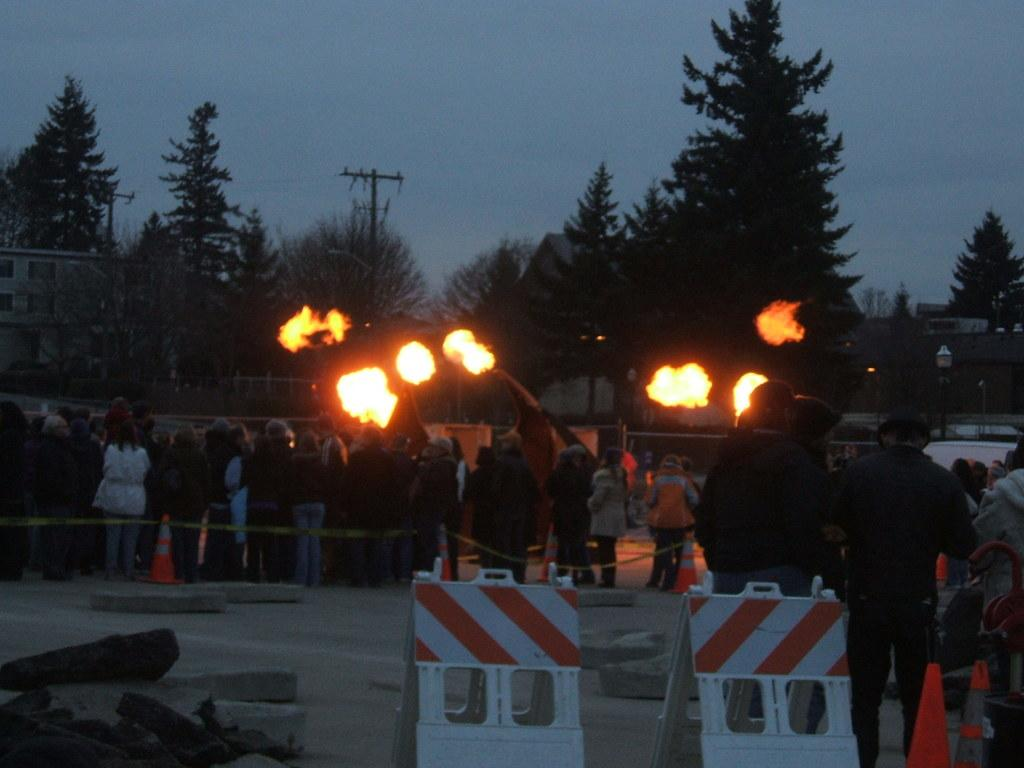What are the people in the image doing? The people in the image are standing in a queue. What is in front of the people in the queue? There are barricades and traffic cones in front of the people. What can be seen in the background of the image? Trees are visible in the image. What is happening to the trees in the image? A fire has caught to the trees. What type of celery can be seen growing near the people in the image? There is no celery present in the image. Can you tell me what time it is by looking at the watch in the image? There is no watch present in the image. 